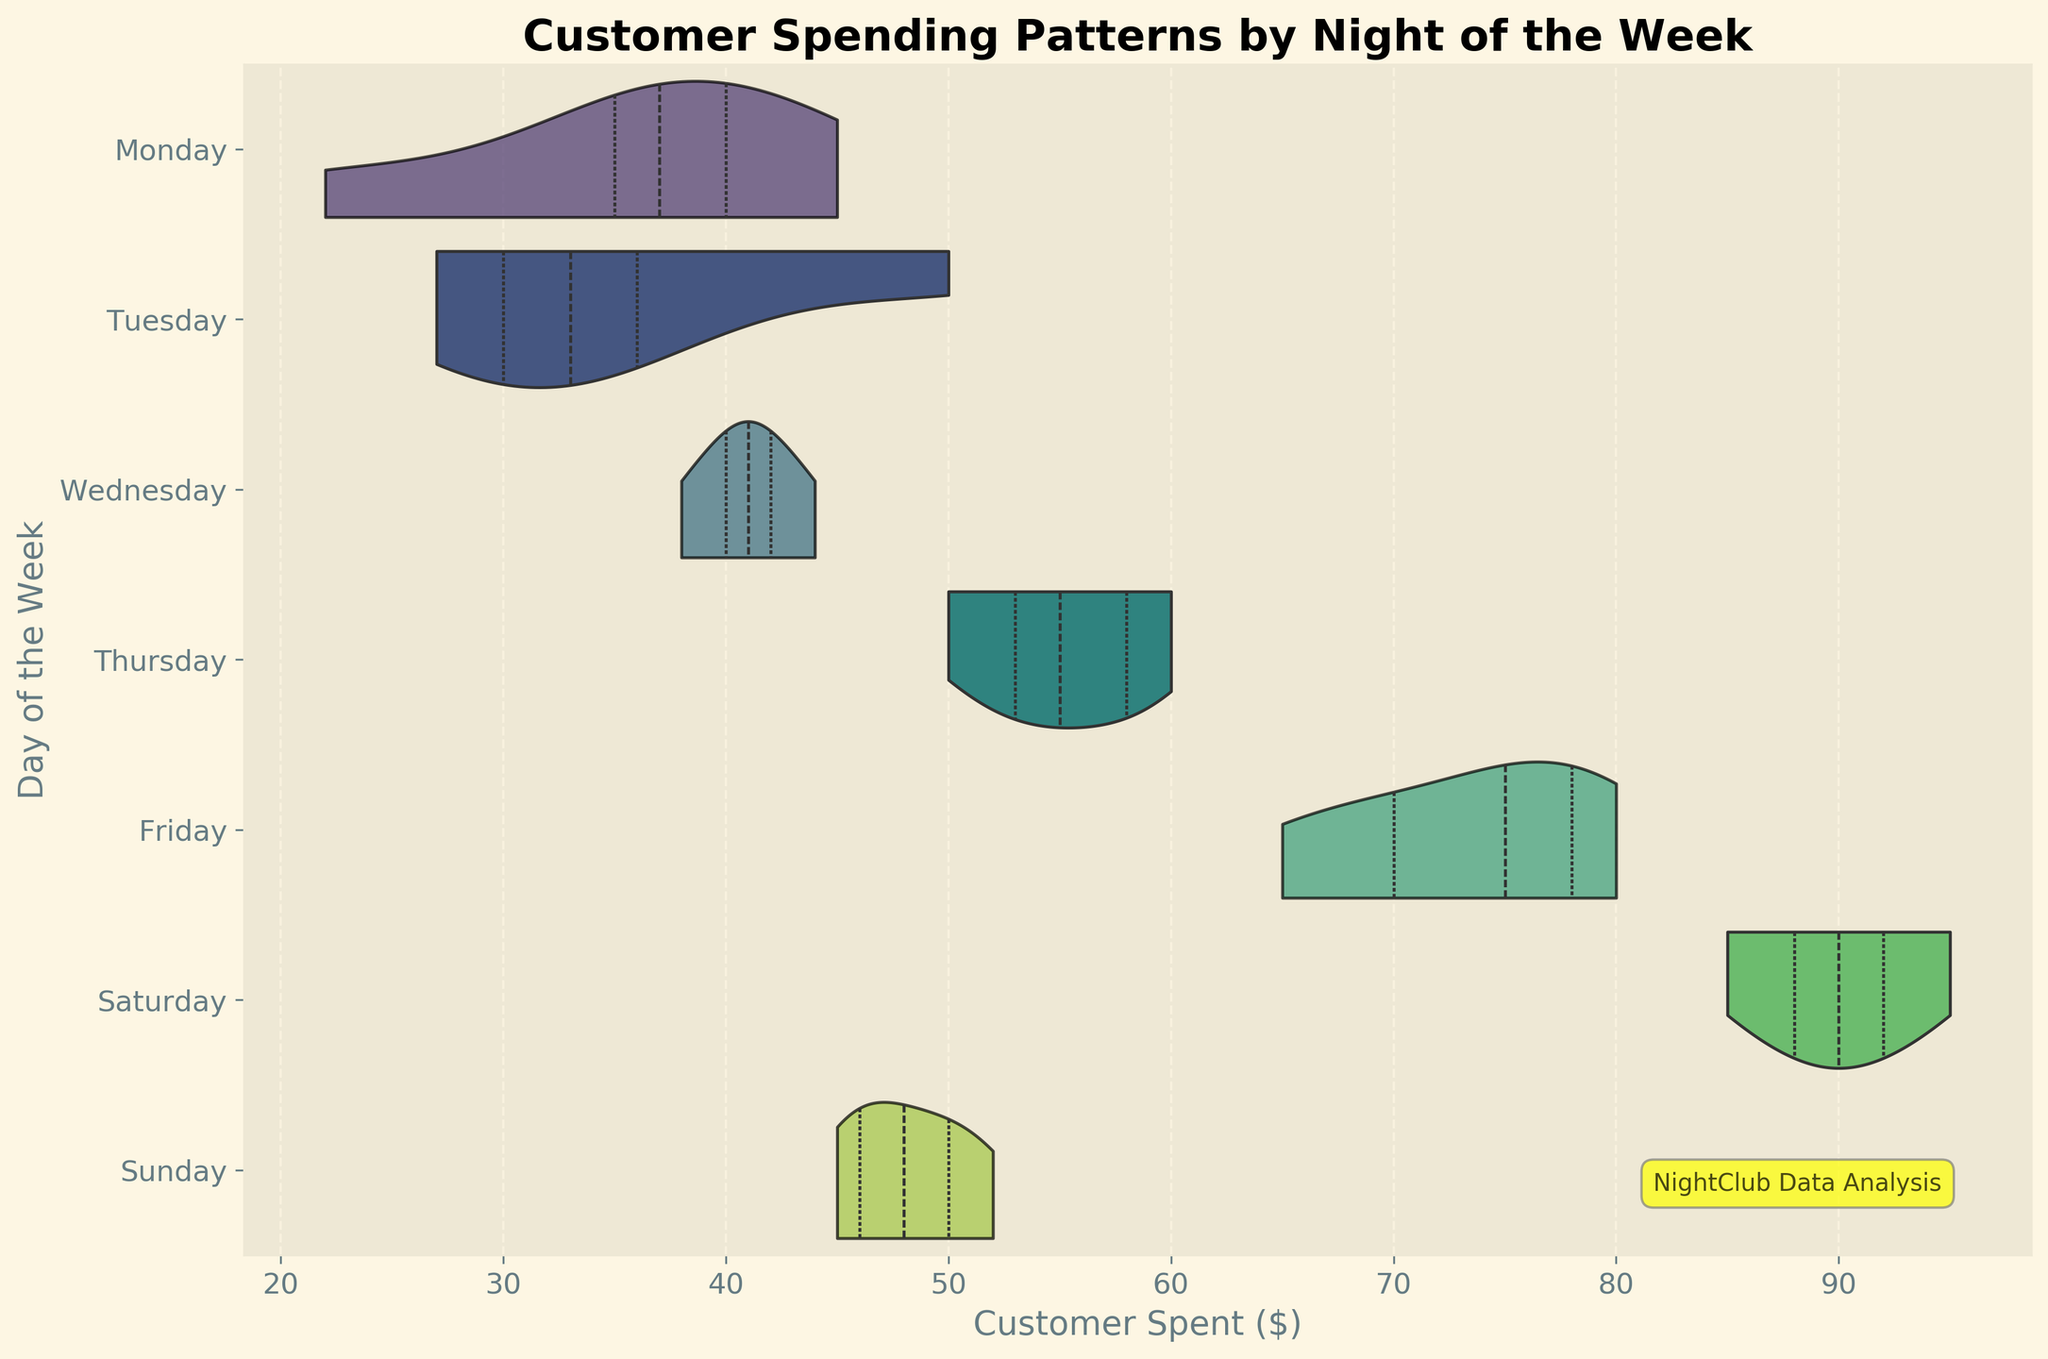What is the title of the chart? The title of the chart is shown at the top, which reads "Customer Spending Patterns by Night of the Week".
Answer: Customer Spending Patterns by Night of the Week Which day shows the highest median customer spending? The violin plots show a white dot representing the median spending for each day. Saturday’s white dot is the highest among all days.
Answer: Saturday Compare customer spending between Friday and Saturday. Which day has a wider spending range? The width of the violin plots indicates the distribution of data. Saturday's plot is wider and shows a greater variation in spending values compared to Friday's.
Answer: Saturday What is the median spending on Monday? The white dot inside the Monday violin plot indicates the median spending, which visually appears to be around $35.
Answer: $35 Which day has the smallest range of customer spending? The range can be seen from the widest areas of the violin plots. Tuesday's plot appears to have the smallest range as it is narrower compared to other days.
Answer: Tuesday How does customer spending on Thursday compare to Tuesday? By comparing the widths and positions of their violin plots, Thursday’s spending is not only higher on average but also has a wider range compared to Tuesday’s.
Answer: Higher and wider range On which night of the week do customers spend between $50 and $60 most often? The bulge in the violin plot between $50 and $60 indicates concentration. Thursday shows a bulge in this range, meaning more customers spend within this interval.
Answer: Thursday What is the approximate interquartile range (IQR) for customer spending on Wednesday? The IQR is represented by the width of the violin plot from the first to the third quartile. For Wednesday, it appears to be from $38 to $42.
Answer: $38 - $42 Which three days have the highest median spending? Observing the white dots for median values in the violin plots, Friday, Saturday, and Sunday have the highest median spending.
Answer: Friday, Saturday, Sunday What is the average customer spending on Friday and Saturday? To find the average, look at the position of the median (white dots) for both days. Friday’s and Saturday’s averages are around $73 and $90 respectively. Sum them up and divide by 2 for the average: (73 + 90) / 2 = 81.5
Answer: $81.5 